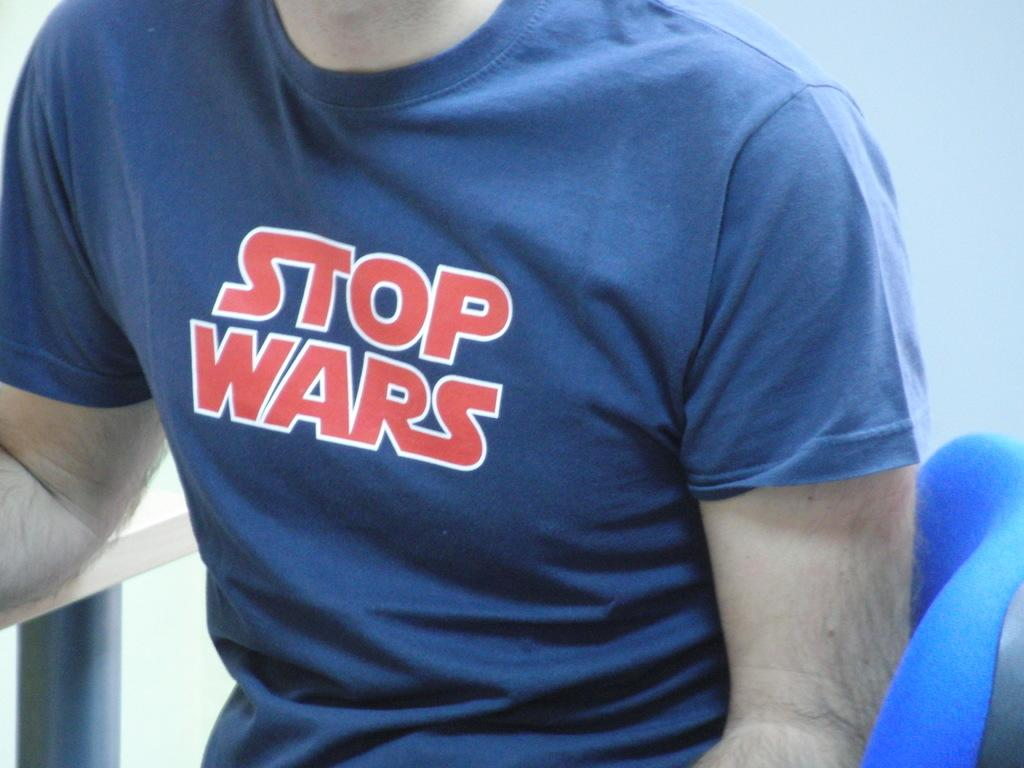<image>
Offer a succinct explanation of the picture presented. The blue short sleeve shirt reads Stop Wars. 